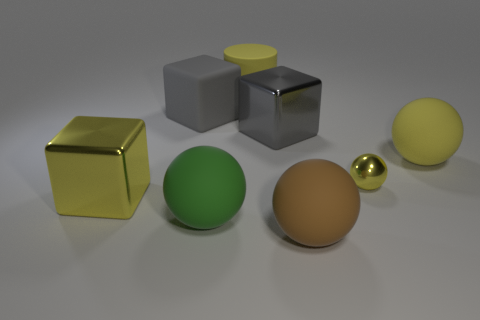The brown ball that is right of the big gray object that is on the right side of the matte cylinder is made of what material?
Keep it short and to the point. Rubber. Is the number of yellow metallic balls in front of the large yellow cylinder greater than the number of cyan matte spheres?
Your answer should be compact. Yes. How many other objects are the same color as the tiny object?
Your answer should be very brief. 3. There is a yellow metallic thing that is the same size as the gray matte cube; what is its shape?
Offer a very short reply. Cube. How many things are in front of the yellow rubber object behind the sphere that is behind the small sphere?
Provide a succinct answer. 7. How many metal things are either large green objects or large cylinders?
Offer a terse response. 0. What is the color of the large thing that is both left of the large brown rubber object and on the right side of the cylinder?
Offer a very short reply. Gray. Does the sphere on the right side of the shiny ball have the same size as the small yellow sphere?
Offer a very short reply. No. What number of things are large yellow rubber things that are to the right of the brown matte sphere or large brown cylinders?
Ensure brevity in your answer.  1. Are there any matte cylinders of the same size as the gray matte block?
Offer a terse response. Yes. 